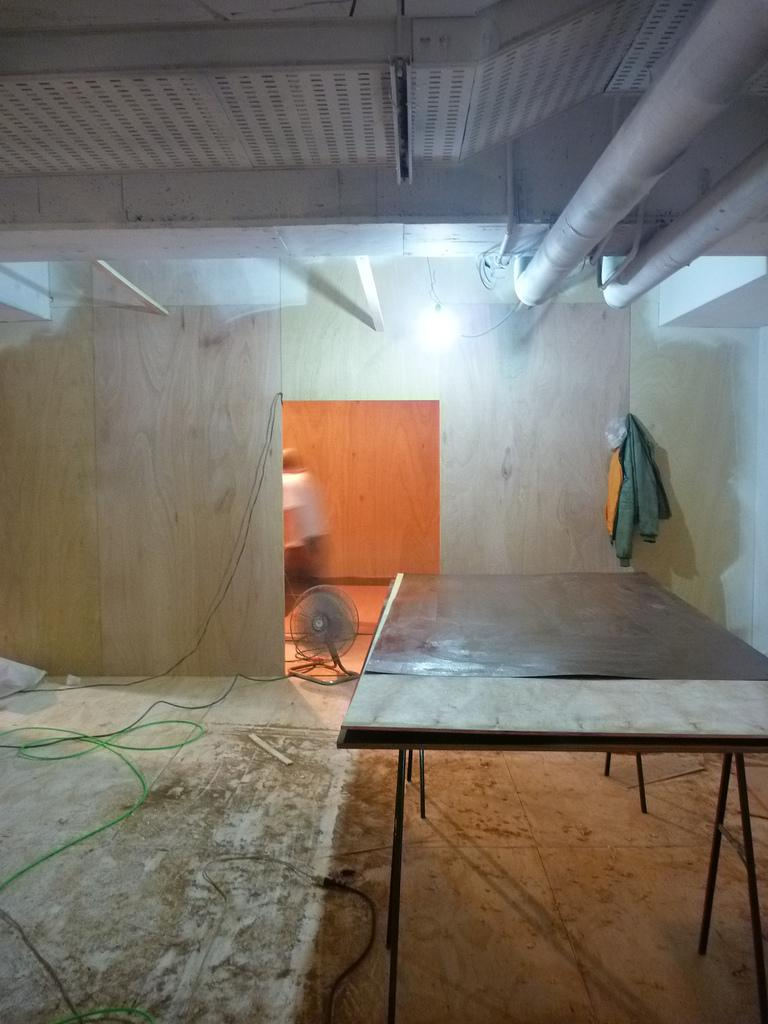What type of fabric is covering the table in the image? There are tablecloths in the image. What can be seen on the wall in the image? There is a wall in the image. What is providing illumination in the image? There is a light source in the image. What type of structure can be seen in the image? There are pipes in the image. What type of credit card is being used to pay for the prison in the image? There is no prison or credit card present in the image. How many stockings are hanging on the wall in the image? There are no stockings visible in the image. 